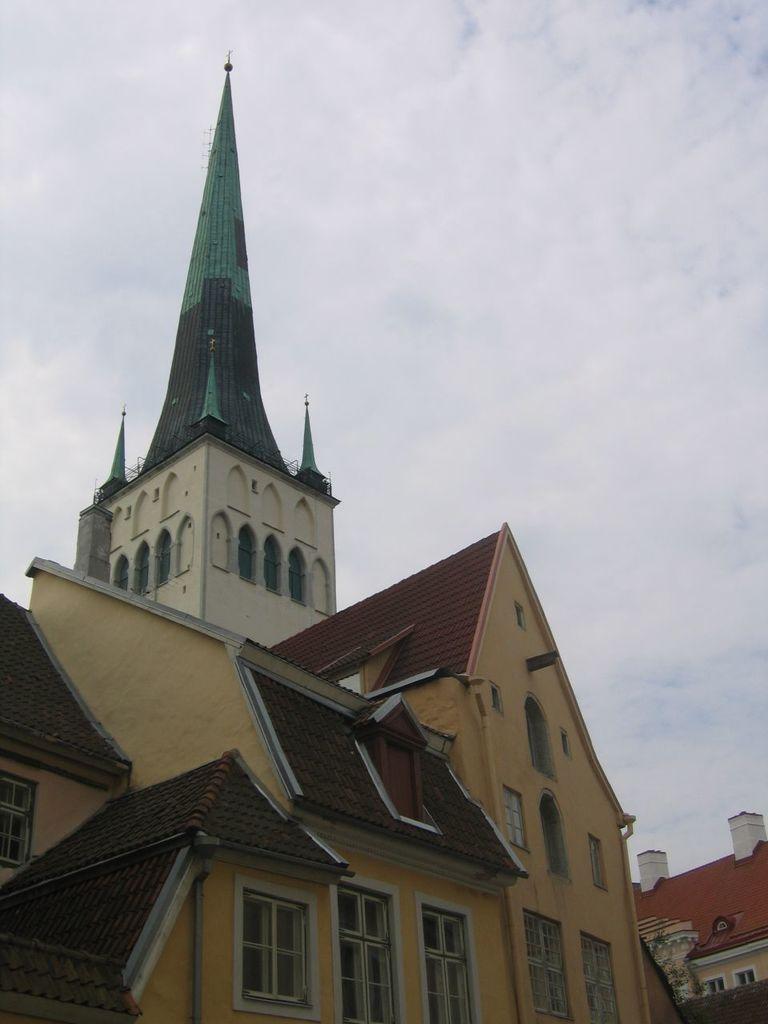Can you describe this image briefly? In this image we can see the buildings. At the top we can see the sky. 